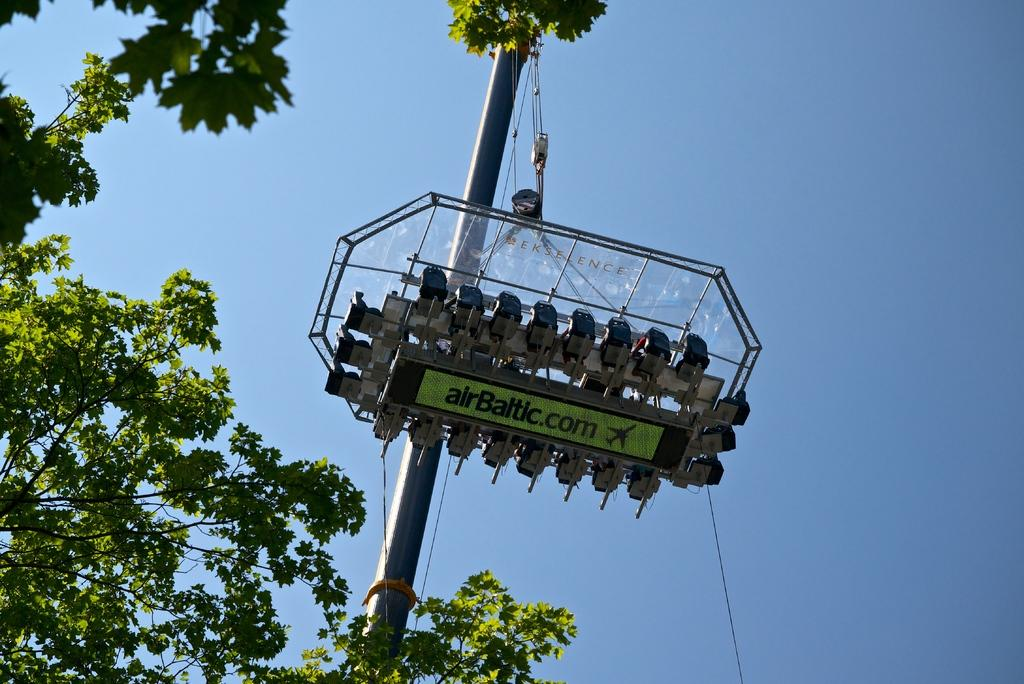What type of vegetation is visible in the front of the image? There are trees in the front of the image. What structure can be seen in the image? There is a pole in the image. What is written or displayed on the pole? There is an object with text on the pole. Can you tell me what type of pie the carpenter is holding in the image? There is no carpenter or pie present in the image. What does the stranger say to the trees in the image? There is no stranger present in the image, and therefore no interaction with the trees can be observed. 